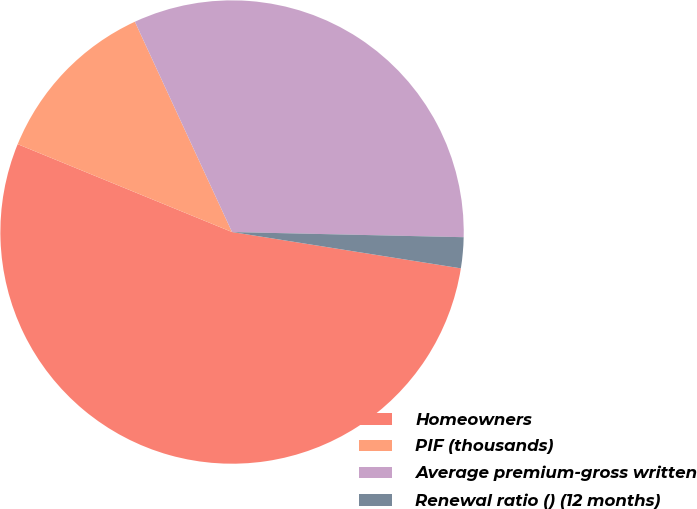<chart> <loc_0><loc_0><loc_500><loc_500><pie_chart><fcel>Homeowners<fcel>PIF (thousands)<fcel>Average premium-gross written<fcel>Renewal ratio () (12 months)<nl><fcel>53.68%<fcel>11.92%<fcel>32.24%<fcel>2.15%<nl></chart> 